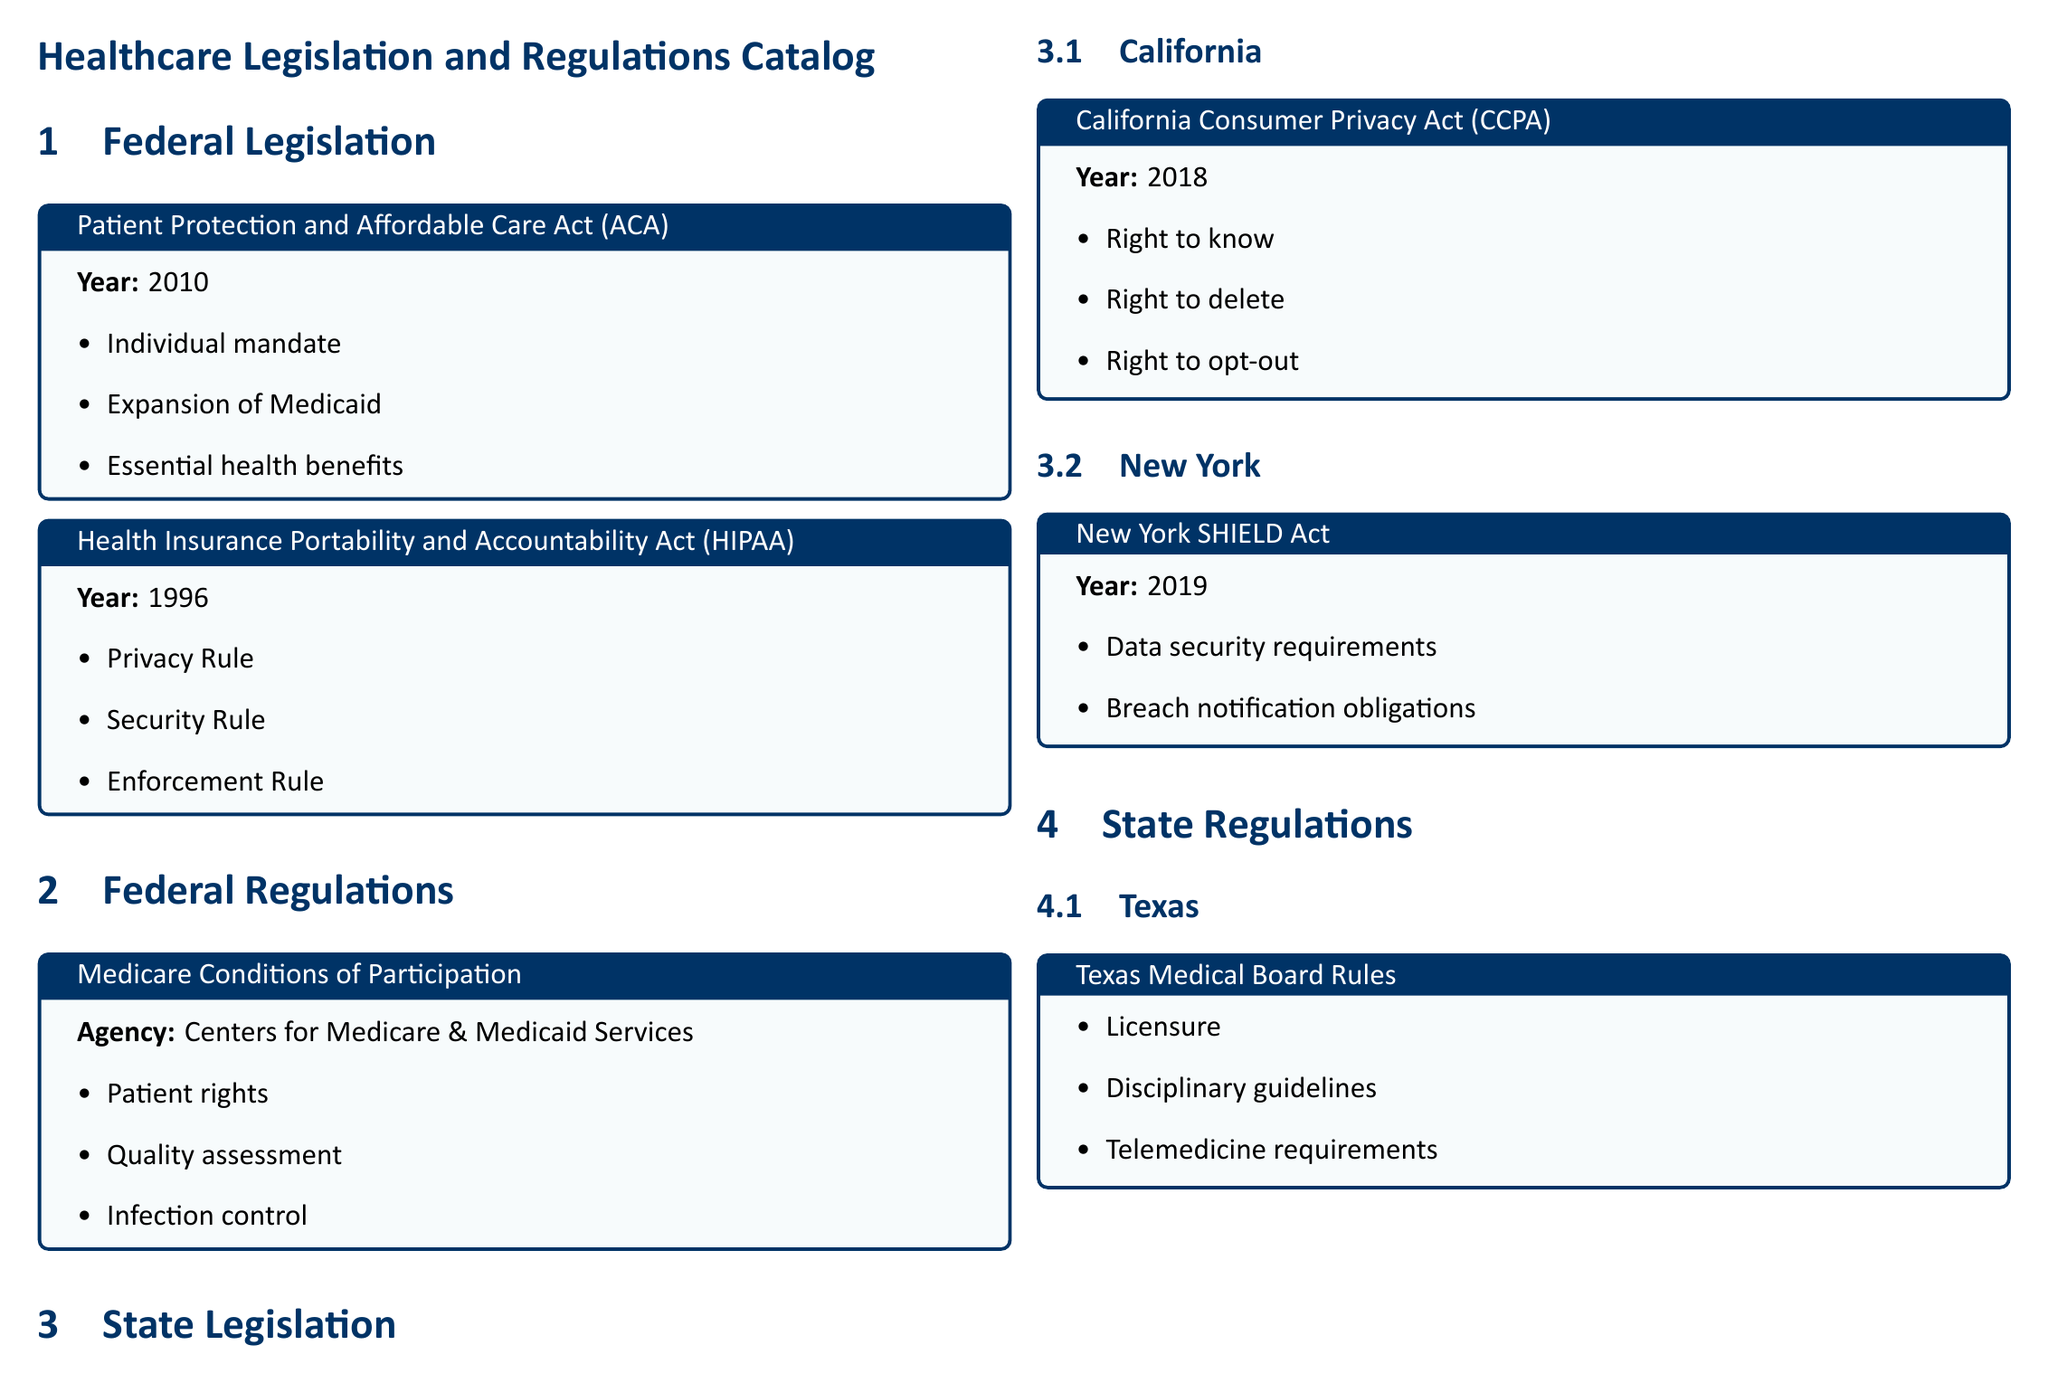What year was the Patient Protection and Affordable Care Act enacted? The document states that the ACA was enacted in the year 2010.
Answer: 2010 What are the essential components of HIPAA? The components of HIPAA listed include the Privacy Rule, Security Rule, and Enforcement Rule as mentioned in the document.
Answer: Privacy Rule, Security Rule, Enforcement Rule Which agency oversees the Medicare Conditions of Participation? The document indicates that the Centers for Medicare & Medicaid Services is the agency responsible for these conditions.
Answer: Centers for Medicare & Medicaid Services What right does the California Consumer Privacy Act provide? The document highlights the rights provided by CCPA, including the right to know, the right to delete, and the right to opt-out.
Answer: Right to know What year was the New York SHIELD Act enacted? The document specifies that the SHIELD Act was enacted in 2019.
Answer: 2019 What topics are covered by the Texas Medical Board Rules? The document outlines that the Texas Medical Board Rules cover Licensure, Disciplinary guidelines, and Telemedicine requirements.
Answer: Licensure, Disciplinary guidelines, Telemedicine requirements How many federal legislation examples are provided in the document? The document lists two examples of federal legislation: ACA and HIPAA.
Answer: 2 What is the primary focus of the Health Insurance Portability and Accountability Act? The document outlines HIPAA's focus is on the protection of patient privacy and security.
Answer: Privacy and security What type of information does the New York SHIELD Act primarily deal with? The document states that the SHIELD Act primarily deals with data security and breach notification obligations.
Answer: Data security and breach notification 